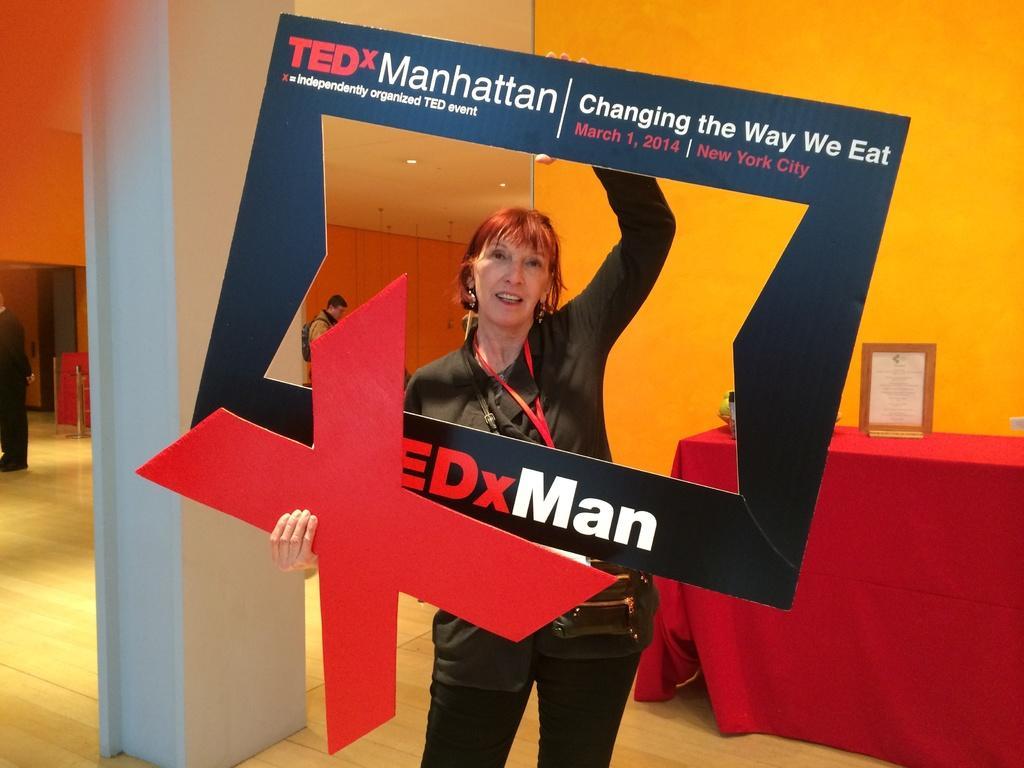Please provide a concise description of this image. In the picture I can see a woman wearing black dress is standing and holding an object in her hands which has something written on it and there is a table in the right corner which has few objects placed on it and there are few persons and some other objects in the background. 